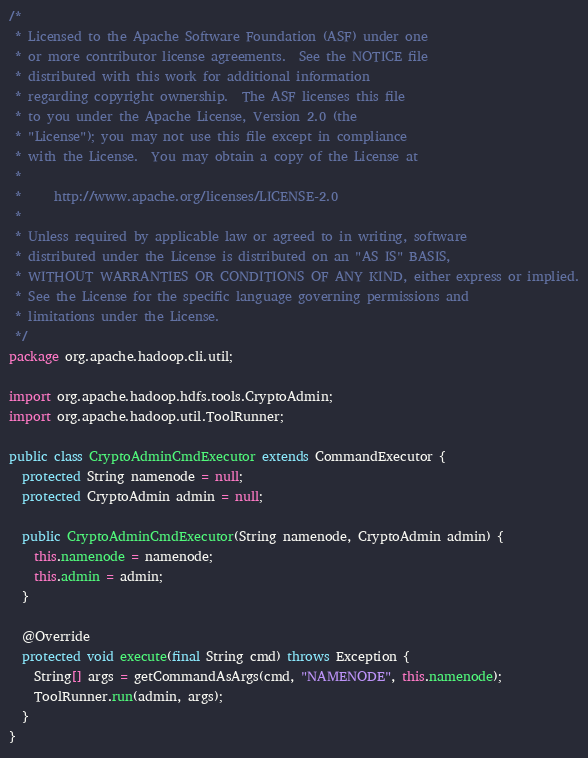<code> <loc_0><loc_0><loc_500><loc_500><_Java_>/*
 * Licensed to the Apache Software Foundation (ASF) under one
 * or more contributor license agreements.  See the NOTICE file
 * distributed with this work for additional information
 * regarding copyright ownership.  The ASF licenses this file
 * to you under the Apache License, Version 2.0 (the
 * "License"); you may not use this file except in compliance
 * with the License.  You may obtain a copy of the License at
 *
 *     http://www.apache.org/licenses/LICENSE-2.0
 *
 * Unless required by applicable law or agreed to in writing, software
 * distributed under the License is distributed on an "AS IS" BASIS,
 * WITHOUT WARRANTIES OR CONDITIONS OF ANY KIND, either express or implied.
 * See the License for the specific language governing permissions and
 * limitations under the License.
 */
package org.apache.hadoop.cli.util;

import org.apache.hadoop.hdfs.tools.CryptoAdmin;
import org.apache.hadoop.util.ToolRunner;

public class CryptoAdminCmdExecutor extends CommandExecutor {
  protected String namenode = null;
  protected CryptoAdmin admin = null;

  public CryptoAdminCmdExecutor(String namenode, CryptoAdmin admin) {
    this.namenode = namenode;
    this.admin = admin;
  }

  @Override
  protected void execute(final String cmd) throws Exception {
    String[] args = getCommandAsArgs(cmd, "NAMENODE", this.namenode);
    ToolRunner.run(admin, args);
  }
}
</code> 